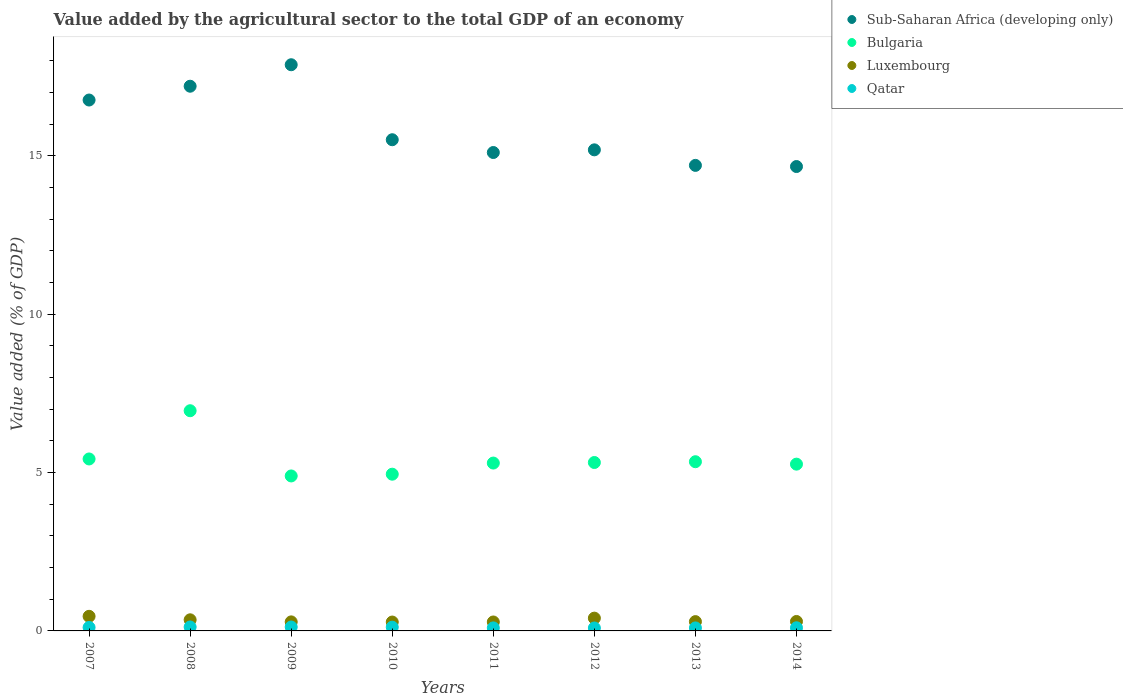How many different coloured dotlines are there?
Ensure brevity in your answer.  4. What is the value added by the agricultural sector to the total GDP in Bulgaria in 2014?
Your response must be concise. 5.27. Across all years, what is the maximum value added by the agricultural sector to the total GDP in Bulgaria?
Provide a succinct answer. 6.95. Across all years, what is the minimum value added by the agricultural sector to the total GDP in Sub-Saharan Africa (developing only)?
Provide a short and direct response. 14.66. What is the total value added by the agricultural sector to the total GDP in Bulgaria in the graph?
Provide a short and direct response. 43.44. What is the difference between the value added by the agricultural sector to the total GDP in Bulgaria in 2007 and that in 2013?
Keep it short and to the point. 0.09. What is the difference between the value added by the agricultural sector to the total GDP in Bulgaria in 2014 and the value added by the agricultural sector to the total GDP in Luxembourg in 2012?
Give a very brief answer. 4.86. What is the average value added by the agricultural sector to the total GDP in Luxembourg per year?
Offer a terse response. 0.33. In the year 2008, what is the difference between the value added by the agricultural sector to the total GDP in Qatar and value added by the agricultural sector to the total GDP in Sub-Saharan Africa (developing only)?
Offer a very short reply. -17.07. What is the ratio of the value added by the agricultural sector to the total GDP in Luxembourg in 2010 to that in 2011?
Offer a terse response. 0.99. Is the value added by the agricultural sector to the total GDP in Luxembourg in 2007 less than that in 2011?
Provide a short and direct response. No. Is the difference between the value added by the agricultural sector to the total GDP in Qatar in 2007 and 2009 greater than the difference between the value added by the agricultural sector to the total GDP in Sub-Saharan Africa (developing only) in 2007 and 2009?
Your answer should be very brief. Yes. What is the difference between the highest and the second highest value added by the agricultural sector to the total GDP in Luxembourg?
Your answer should be very brief. 0.06. What is the difference between the highest and the lowest value added by the agricultural sector to the total GDP in Sub-Saharan Africa (developing only)?
Give a very brief answer. 3.21. In how many years, is the value added by the agricultural sector to the total GDP in Qatar greater than the average value added by the agricultural sector to the total GDP in Qatar taken over all years?
Your response must be concise. 4. How many years are there in the graph?
Your answer should be very brief. 8. What is the difference between two consecutive major ticks on the Y-axis?
Ensure brevity in your answer.  5. Does the graph contain grids?
Give a very brief answer. No. How many legend labels are there?
Provide a succinct answer. 4. How are the legend labels stacked?
Your answer should be compact. Vertical. What is the title of the graph?
Your answer should be compact. Value added by the agricultural sector to the total GDP of an economy. Does "Saudi Arabia" appear as one of the legend labels in the graph?
Your response must be concise. No. What is the label or title of the X-axis?
Offer a terse response. Years. What is the label or title of the Y-axis?
Provide a succinct answer. Value added (% of GDP). What is the Value added (% of GDP) in Sub-Saharan Africa (developing only) in 2007?
Your response must be concise. 16.76. What is the Value added (% of GDP) in Bulgaria in 2007?
Provide a succinct answer. 5.43. What is the Value added (% of GDP) in Luxembourg in 2007?
Provide a short and direct response. 0.46. What is the Value added (% of GDP) in Qatar in 2007?
Your response must be concise. 0.11. What is the Value added (% of GDP) of Sub-Saharan Africa (developing only) in 2008?
Your answer should be very brief. 17.2. What is the Value added (% of GDP) of Bulgaria in 2008?
Offer a very short reply. 6.95. What is the Value added (% of GDP) in Luxembourg in 2008?
Your response must be concise. 0.35. What is the Value added (% of GDP) of Qatar in 2008?
Make the answer very short. 0.12. What is the Value added (% of GDP) in Sub-Saharan Africa (developing only) in 2009?
Provide a succinct answer. 17.87. What is the Value added (% of GDP) of Bulgaria in 2009?
Offer a terse response. 4.89. What is the Value added (% of GDP) in Luxembourg in 2009?
Your answer should be compact. 0.29. What is the Value added (% of GDP) in Qatar in 2009?
Make the answer very short. 0.12. What is the Value added (% of GDP) of Sub-Saharan Africa (developing only) in 2010?
Make the answer very short. 15.51. What is the Value added (% of GDP) of Bulgaria in 2010?
Make the answer very short. 4.95. What is the Value added (% of GDP) of Luxembourg in 2010?
Provide a succinct answer. 0.28. What is the Value added (% of GDP) of Qatar in 2010?
Provide a succinct answer. 0.12. What is the Value added (% of GDP) of Sub-Saharan Africa (developing only) in 2011?
Your answer should be compact. 15.1. What is the Value added (% of GDP) of Bulgaria in 2011?
Your answer should be very brief. 5.3. What is the Value added (% of GDP) of Luxembourg in 2011?
Make the answer very short. 0.28. What is the Value added (% of GDP) in Qatar in 2011?
Keep it short and to the point. 0.1. What is the Value added (% of GDP) in Sub-Saharan Africa (developing only) in 2012?
Provide a succinct answer. 15.19. What is the Value added (% of GDP) of Bulgaria in 2012?
Offer a terse response. 5.32. What is the Value added (% of GDP) in Luxembourg in 2012?
Offer a terse response. 0.4. What is the Value added (% of GDP) of Qatar in 2012?
Provide a short and direct response. 0.09. What is the Value added (% of GDP) of Sub-Saharan Africa (developing only) in 2013?
Offer a very short reply. 14.7. What is the Value added (% of GDP) of Bulgaria in 2013?
Provide a short and direct response. 5.34. What is the Value added (% of GDP) in Luxembourg in 2013?
Provide a short and direct response. 0.29. What is the Value added (% of GDP) of Qatar in 2013?
Provide a succinct answer. 0.09. What is the Value added (% of GDP) in Sub-Saharan Africa (developing only) in 2014?
Offer a very short reply. 14.66. What is the Value added (% of GDP) in Bulgaria in 2014?
Make the answer very short. 5.27. What is the Value added (% of GDP) of Luxembourg in 2014?
Ensure brevity in your answer.  0.3. What is the Value added (% of GDP) in Qatar in 2014?
Your response must be concise. 0.1. Across all years, what is the maximum Value added (% of GDP) in Sub-Saharan Africa (developing only)?
Offer a terse response. 17.87. Across all years, what is the maximum Value added (% of GDP) in Bulgaria?
Offer a terse response. 6.95. Across all years, what is the maximum Value added (% of GDP) of Luxembourg?
Ensure brevity in your answer.  0.46. Across all years, what is the maximum Value added (% of GDP) in Qatar?
Offer a very short reply. 0.12. Across all years, what is the minimum Value added (% of GDP) in Sub-Saharan Africa (developing only)?
Your response must be concise. 14.66. Across all years, what is the minimum Value added (% of GDP) of Bulgaria?
Offer a terse response. 4.89. Across all years, what is the minimum Value added (% of GDP) of Luxembourg?
Provide a short and direct response. 0.28. Across all years, what is the minimum Value added (% of GDP) in Qatar?
Give a very brief answer. 0.09. What is the total Value added (% of GDP) in Sub-Saharan Africa (developing only) in the graph?
Ensure brevity in your answer.  126.98. What is the total Value added (% of GDP) in Bulgaria in the graph?
Offer a terse response. 43.44. What is the total Value added (% of GDP) in Luxembourg in the graph?
Keep it short and to the point. 2.65. What is the total Value added (% of GDP) of Qatar in the graph?
Provide a succinct answer. 0.86. What is the difference between the Value added (% of GDP) of Sub-Saharan Africa (developing only) in 2007 and that in 2008?
Offer a terse response. -0.44. What is the difference between the Value added (% of GDP) of Bulgaria in 2007 and that in 2008?
Your answer should be compact. -1.52. What is the difference between the Value added (% of GDP) of Luxembourg in 2007 and that in 2008?
Your answer should be very brief. 0.11. What is the difference between the Value added (% of GDP) in Qatar in 2007 and that in 2008?
Keep it short and to the point. -0.01. What is the difference between the Value added (% of GDP) of Sub-Saharan Africa (developing only) in 2007 and that in 2009?
Provide a short and direct response. -1.11. What is the difference between the Value added (% of GDP) of Bulgaria in 2007 and that in 2009?
Your answer should be compact. 0.54. What is the difference between the Value added (% of GDP) of Luxembourg in 2007 and that in 2009?
Give a very brief answer. 0.18. What is the difference between the Value added (% of GDP) of Qatar in 2007 and that in 2009?
Offer a terse response. -0.01. What is the difference between the Value added (% of GDP) in Sub-Saharan Africa (developing only) in 2007 and that in 2010?
Provide a short and direct response. 1.25. What is the difference between the Value added (% of GDP) of Bulgaria in 2007 and that in 2010?
Your answer should be very brief. 0.48. What is the difference between the Value added (% of GDP) in Luxembourg in 2007 and that in 2010?
Keep it short and to the point. 0.18. What is the difference between the Value added (% of GDP) in Qatar in 2007 and that in 2010?
Keep it short and to the point. -0.01. What is the difference between the Value added (% of GDP) of Sub-Saharan Africa (developing only) in 2007 and that in 2011?
Provide a short and direct response. 1.66. What is the difference between the Value added (% of GDP) of Bulgaria in 2007 and that in 2011?
Provide a short and direct response. 0.13. What is the difference between the Value added (% of GDP) of Luxembourg in 2007 and that in 2011?
Keep it short and to the point. 0.18. What is the difference between the Value added (% of GDP) in Qatar in 2007 and that in 2011?
Your answer should be compact. 0.01. What is the difference between the Value added (% of GDP) of Sub-Saharan Africa (developing only) in 2007 and that in 2012?
Offer a terse response. 1.57. What is the difference between the Value added (% of GDP) in Bulgaria in 2007 and that in 2012?
Your answer should be compact. 0.11. What is the difference between the Value added (% of GDP) of Luxembourg in 2007 and that in 2012?
Keep it short and to the point. 0.06. What is the difference between the Value added (% of GDP) of Qatar in 2007 and that in 2012?
Provide a succinct answer. 0.02. What is the difference between the Value added (% of GDP) of Sub-Saharan Africa (developing only) in 2007 and that in 2013?
Make the answer very short. 2.06. What is the difference between the Value added (% of GDP) in Bulgaria in 2007 and that in 2013?
Ensure brevity in your answer.  0.09. What is the difference between the Value added (% of GDP) in Luxembourg in 2007 and that in 2013?
Your answer should be compact. 0.17. What is the difference between the Value added (% of GDP) of Qatar in 2007 and that in 2013?
Ensure brevity in your answer.  0.02. What is the difference between the Value added (% of GDP) in Sub-Saharan Africa (developing only) in 2007 and that in 2014?
Your answer should be very brief. 2.1. What is the difference between the Value added (% of GDP) in Bulgaria in 2007 and that in 2014?
Provide a short and direct response. 0.16. What is the difference between the Value added (% of GDP) in Luxembourg in 2007 and that in 2014?
Offer a terse response. 0.16. What is the difference between the Value added (% of GDP) of Qatar in 2007 and that in 2014?
Ensure brevity in your answer.  0.01. What is the difference between the Value added (% of GDP) of Sub-Saharan Africa (developing only) in 2008 and that in 2009?
Ensure brevity in your answer.  -0.68. What is the difference between the Value added (% of GDP) of Bulgaria in 2008 and that in 2009?
Offer a very short reply. 2.06. What is the difference between the Value added (% of GDP) in Luxembourg in 2008 and that in 2009?
Your answer should be compact. 0.07. What is the difference between the Value added (% of GDP) of Qatar in 2008 and that in 2009?
Give a very brief answer. 0. What is the difference between the Value added (% of GDP) of Sub-Saharan Africa (developing only) in 2008 and that in 2010?
Give a very brief answer. 1.69. What is the difference between the Value added (% of GDP) of Bulgaria in 2008 and that in 2010?
Provide a short and direct response. 2. What is the difference between the Value added (% of GDP) of Luxembourg in 2008 and that in 2010?
Your answer should be very brief. 0.07. What is the difference between the Value added (% of GDP) of Qatar in 2008 and that in 2010?
Offer a very short reply. 0.01. What is the difference between the Value added (% of GDP) in Sub-Saharan Africa (developing only) in 2008 and that in 2011?
Your answer should be very brief. 2.09. What is the difference between the Value added (% of GDP) of Bulgaria in 2008 and that in 2011?
Your answer should be very brief. 1.65. What is the difference between the Value added (% of GDP) in Luxembourg in 2008 and that in 2011?
Make the answer very short. 0.07. What is the difference between the Value added (% of GDP) of Qatar in 2008 and that in 2011?
Your answer should be compact. 0.03. What is the difference between the Value added (% of GDP) in Sub-Saharan Africa (developing only) in 2008 and that in 2012?
Your response must be concise. 2.01. What is the difference between the Value added (% of GDP) of Bulgaria in 2008 and that in 2012?
Provide a short and direct response. 1.63. What is the difference between the Value added (% of GDP) of Luxembourg in 2008 and that in 2012?
Offer a very short reply. -0.05. What is the difference between the Value added (% of GDP) in Qatar in 2008 and that in 2012?
Make the answer very short. 0.03. What is the difference between the Value added (% of GDP) of Sub-Saharan Africa (developing only) in 2008 and that in 2013?
Keep it short and to the point. 2.5. What is the difference between the Value added (% of GDP) in Bulgaria in 2008 and that in 2013?
Offer a very short reply. 1.61. What is the difference between the Value added (% of GDP) in Luxembourg in 2008 and that in 2013?
Offer a terse response. 0.06. What is the difference between the Value added (% of GDP) of Qatar in 2008 and that in 2013?
Give a very brief answer. 0.03. What is the difference between the Value added (% of GDP) in Sub-Saharan Africa (developing only) in 2008 and that in 2014?
Give a very brief answer. 2.54. What is the difference between the Value added (% of GDP) of Bulgaria in 2008 and that in 2014?
Your answer should be compact. 1.69. What is the difference between the Value added (% of GDP) of Luxembourg in 2008 and that in 2014?
Your answer should be very brief. 0.05. What is the difference between the Value added (% of GDP) of Qatar in 2008 and that in 2014?
Offer a terse response. 0.03. What is the difference between the Value added (% of GDP) of Sub-Saharan Africa (developing only) in 2009 and that in 2010?
Offer a terse response. 2.37. What is the difference between the Value added (% of GDP) in Bulgaria in 2009 and that in 2010?
Offer a very short reply. -0.06. What is the difference between the Value added (% of GDP) in Luxembourg in 2009 and that in 2010?
Provide a succinct answer. 0.01. What is the difference between the Value added (% of GDP) of Qatar in 2009 and that in 2010?
Provide a short and direct response. 0.01. What is the difference between the Value added (% of GDP) in Sub-Saharan Africa (developing only) in 2009 and that in 2011?
Keep it short and to the point. 2.77. What is the difference between the Value added (% of GDP) in Bulgaria in 2009 and that in 2011?
Your response must be concise. -0.41. What is the difference between the Value added (% of GDP) in Luxembourg in 2009 and that in 2011?
Provide a succinct answer. 0. What is the difference between the Value added (% of GDP) in Qatar in 2009 and that in 2011?
Offer a very short reply. 0.03. What is the difference between the Value added (% of GDP) in Sub-Saharan Africa (developing only) in 2009 and that in 2012?
Offer a terse response. 2.69. What is the difference between the Value added (% of GDP) in Bulgaria in 2009 and that in 2012?
Offer a terse response. -0.42. What is the difference between the Value added (% of GDP) of Luxembourg in 2009 and that in 2012?
Offer a terse response. -0.12. What is the difference between the Value added (% of GDP) in Qatar in 2009 and that in 2012?
Your response must be concise. 0.03. What is the difference between the Value added (% of GDP) in Sub-Saharan Africa (developing only) in 2009 and that in 2013?
Offer a very short reply. 3.18. What is the difference between the Value added (% of GDP) in Bulgaria in 2009 and that in 2013?
Offer a very short reply. -0.45. What is the difference between the Value added (% of GDP) of Luxembourg in 2009 and that in 2013?
Your response must be concise. -0.01. What is the difference between the Value added (% of GDP) in Qatar in 2009 and that in 2013?
Your response must be concise. 0.03. What is the difference between the Value added (% of GDP) of Sub-Saharan Africa (developing only) in 2009 and that in 2014?
Offer a very short reply. 3.21. What is the difference between the Value added (% of GDP) of Bulgaria in 2009 and that in 2014?
Your answer should be compact. -0.37. What is the difference between the Value added (% of GDP) of Luxembourg in 2009 and that in 2014?
Keep it short and to the point. -0.01. What is the difference between the Value added (% of GDP) of Qatar in 2009 and that in 2014?
Your answer should be very brief. 0.02. What is the difference between the Value added (% of GDP) in Sub-Saharan Africa (developing only) in 2010 and that in 2011?
Offer a terse response. 0.4. What is the difference between the Value added (% of GDP) of Bulgaria in 2010 and that in 2011?
Your answer should be compact. -0.35. What is the difference between the Value added (% of GDP) in Luxembourg in 2010 and that in 2011?
Provide a succinct answer. -0. What is the difference between the Value added (% of GDP) in Qatar in 2010 and that in 2011?
Your answer should be compact. 0.02. What is the difference between the Value added (% of GDP) in Sub-Saharan Africa (developing only) in 2010 and that in 2012?
Give a very brief answer. 0.32. What is the difference between the Value added (% of GDP) in Bulgaria in 2010 and that in 2012?
Provide a short and direct response. -0.37. What is the difference between the Value added (% of GDP) of Luxembourg in 2010 and that in 2012?
Provide a succinct answer. -0.12. What is the difference between the Value added (% of GDP) of Qatar in 2010 and that in 2012?
Offer a terse response. 0.03. What is the difference between the Value added (% of GDP) of Sub-Saharan Africa (developing only) in 2010 and that in 2013?
Keep it short and to the point. 0.81. What is the difference between the Value added (% of GDP) of Bulgaria in 2010 and that in 2013?
Make the answer very short. -0.39. What is the difference between the Value added (% of GDP) of Luxembourg in 2010 and that in 2013?
Offer a very short reply. -0.01. What is the difference between the Value added (% of GDP) of Qatar in 2010 and that in 2013?
Keep it short and to the point. 0.02. What is the difference between the Value added (% of GDP) in Sub-Saharan Africa (developing only) in 2010 and that in 2014?
Your answer should be very brief. 0.85. What is the difference between the Value added (% of GDP) in Bulgaria in 2010 and that in 2014?
Provide a short and direct response. -0.32. What is the difference between the Value added (% of GDP) of Luxembourg in 2010 and that in 2014?
Provide a succinct answer. -0.02. What is the difference between the Value added (% of GDP) in Qatar in 2010 and that in 2014?
Offer a very short reply. 0.02. What is the difference between the Value added (% of GDP) in Sub-Saharan Africa (developing only) in 2011 and that in 2012?
Offer a very short reply. -0.08. What is the difference between the Value added (% of GDP) of Bulgaria in 2011 and that in 2012?
Provide a succinct answer. -0.02. What is the difference between the Value added (% of GDP) of Luxembourg in 2011 and that in 2012?
Offer a very short reply. -0.12. What is the difference between the Value added (% of GDP) of Qatar in 2011 and that in 2012?
Make the answer very short. 0. What is the difference between the Value added (% of GDP) in Sub-Saharan Africa (developing only) in 2011 and that in 2013?
Make the answer very short. 0.41. What is the difference between the Value added (% of GDP) of Bulgaria in 2011 and that in 2013?
Ensure brevity in your answer.  -0.04. What is the difference between the Value added (% of GDP) of Luxembourg in 2011 and that in 2013?
Offer a very short reply. -0.01. What is the difference between the Value added (% of GDP) in Qatar in 2011 and that in 2013?
Make the answer very short. 0. What is the difference between the Value added (% of GDP) of Sub-Saharan Africa (developing only) in 2011 and that in 2014?
Make the answer very short. 0.44. What is the difference between the Value added (% of GDP) in Bulgaria in 2011 and that in 2014?
Provide a succinct answer. 0.03. What is the difference between the Value added (% of GDP) of Luxembourg in 2011 and that in 2014?
Make the answer very short. -0.02. What is the difference between the Value added (% of GDP) of Qatar in 2011 and that in 2014?
Provide a short and direct response. -0. What is the difference between the Value added (% of GDP) in Sub-Saharan Africa (developing only) in 2012 and that in 2013?
Give a very brief answer. 0.49. What is the difference between the Value added (% of GDP) of Bulgaria in 2012 and that in 2013?
Your response must be concise. -0.02. What is the difference between the Value added (% of GDP) in Luxembourg in 2012 and that in 2013?
Ensure brevity in your answer.  0.11. What is the difference between the Value added (% of GDP) of Qatar in 2012 and that in 2013?
Make the answer very short. -0. What is the difference between the Value added (% of GDP) of Sub-Saharan Africa (developing only) in 2012 and that in 2014?
Your response must be concise. 0.53. What is the difference between the Value added (% of GDP) of Bulgaria in 2012 and that in 2014?
Provide a succinct answer. 0.05. What is the difference between the Value added (% of GDP) in Luxembourg in 2012 and that in 2014?
Your answer should be very brief. 0.11. What is the difference between the Value added (% of GDP) in Qatar in 2012 and that in 2014?
Your response must be concise. -0.01. What is the difference between the Value added (% of GDP) of Sub-Saharan Africa (developing only) in 2013 and that in 2014?
Ensure brevity in your answer.  0.04. What is the difference between the Value added (% of GDP) in Bulgaria in 2013 and that in 2014?
Offer a very short reply. 0.08. What is the difference between the Value added (% of GDP) in Luxembourg in 2013 and that in 2014?
Make the answer very short. -0. What is the difference between the Value added (% of GDP) of Qatar in 2013 and that in 2014?
Offer a terse response. -0. What is the difference between the Value added (% of GDP) in Sub-Saharan Africa (developing only) in 2007 and the Value added (% of GDP) in Bulgaria in 2008?
Your answer should be compact. 9.81. What is the difference between the Value added (% of GDP) of Sub-Saharan Africa (developing only) in 2007 and the Value added (% of GDP) of Luxembourg in 2008?
Provide a succinct answer. 16.41. What is the difference between the Value added (% of GDP) of Sub-Saharan Africa (developing only) in 2007 and the Value added (% of GDP) of Qatar in 2008?
Provide a short and direct response. 16.64. What is the difference between the Value added (% of GDP) in Bulgaria in 2007 and the Value added (% of GDP) in Luxembourg in 2008?
Offer a terse response. 5.08. What is the difference between the Value added (% of GDP) in Bulgaria in 2007 and the Value added (% of GDP) in Qatar in 2008?
Offer a very short reply. 5.3. What is the difference between the Value added (% of GDP) in Luxembourg in 2007 and the Value added (% of GDP) in Qatar in 2008?
Your answer should be compact. 0.34. What is the difference between the Value added (% of GDP) of Sub-Saharan Africa (developing only) in 2007 and the Value added (% of GDP) of Bulgaria in 2009?
Your response must be concise. 11.87. What is the difference between the Value added (% of GDP) of Sub-Saharan Africa (developing only) in 2007 and the Value added (% of GDP) of Luxembourg in 2009?
Provide a short and direct response. 16.47. What is the difference between the Value added (% of GDP) in Sub-Saharan Africa (developing only) in 2007 and the Value added (% of GDP) in Qatar in 2009?
Offer a terse response. 16.64. What is the difference between the Value added (% of GDP) in Bulgaria in 2007 and the Value added (% of GDP) in Luxembourg in 2009?
Your answer should be compact. 5.14. What is the difference between the Value added (% of GDP) of Bulgaria in 2007 and the Value added (% of GDP) of Qatar in 2009?
Your response must be concise. 5.31. What is the difference between the Value added (% of GDP) in Luxembourg in 2007 and the Value added (% of GDP) in Qatar in 2009?
Provide a short and direct response. 0.34. What is the difference between the Value added (% of GDP) in Sub-Saharan Africa (developing only) in 2007 and the Value added (% of GDP) in Bulgaria in 2010?
Your response must be concise. 11.81. What is the difference between the Value added (% of GDP) in Sub-Saharan Africa (developing only) in 2007 and the Value added (% of GDP) in Luxembourg in 2010?
Keep it short and to the point. 16.48. What is the difference between the Value added (% of GDP) of Sub-Saharan Africa (developing only) in 2007 and the Value added (% of GDP) of Qatar in 2010?
Keep it short and to the point. 16.64. What is the difference between the Value added (% of GDP) of Bulgaria in 2007 and the Value added (% of GDP) of Luxembourg in 2010?
Ensure brevity in your answer.  5.15. What is the difference between the Value added (% of GDP) in Bulgaria in 2007 and the Value added (% of GDP) in Qatar in 2010?
Your answer should be very brief. 5.31. What is the difference between the Value added (% of GDP) of Luxembourg in 2007 and the Value added (% of GDP) of Qatar in 2010?
Provide a succinct answer. 0.34. What is the difference between the Value added (% of GDP) in Sub-Saharan Africa (developing only) in 2007 and the Value added (% of GDP) in Bulgaria in 2011?
Your answer should be very brief. 11.46. What is the difference between the Value added (% of GDP) of Sub-Saharan Africa (developing only) in 2007 and the Value added (% of GDP) of Luxembourg in 2011?
Give a very brief answer. 16.48. What is the difference between the Value added (% of GDP) in Sub-Saharan Africa (developing only) in 2007 and the Value added (% of GDP) in Qatar in 2011?
Give a very brief answer. 16.66. What is the difference between the Value added (% of GDP) in Bulgaria in 2007 and the Value added (% of GDP) in Luxembourg in 2011?
Provide a short and direct response. 5.15. What is the difference between the Value added (% of GDP) in Bulgaria in 2007 and the Value added (% of GDP) in Qatar in 2011?
Give a very brief answer. 5.33. What is the difference between the Value added (% of GDP) of Luxembourg in 2007 and the Value added (% of GDP) of Qatar in 2011?
Offer a terse response. 0.37. What is the difference between the Value added (% of GDP) in Sub-Saharan Africa (developing only) in 2007 and the Value added (% of GDP) in Bulgaria in 2012?
Provide a short and direct response. 11.44. What is the difference between the Value added (% of GDP) of Sub-Saharan Africa (developing only) in 2007 and the Value added (% of GDP) of Luxembourg in 2012?
Ensure brevity in your answer.  16.36. What is the difference between the Value added (% of GDP) of Sub-Saharan Africa (developing only) in 2007 and the Value added (% of GDP) of Qatar in 2012?
Your answer should be very brief. 16.67. What is the difference between the Value added (% of GDP) of Bulgaria in 2007 and the Value added (% of GDP) of Luxembourg in 2012?
Offer a very short reply. 5.03. What is the difference between the Value added (% of GDP) of Bulgaria in 2007 and the Value added (% of GDP) of Qatar in 2012?
Provide a short and direct response. 5.34. What is the difference between the Value added (% of GDP) in Luxembourg in 2007 and the Value added (% of GDP) in Qatar in 2012?
Give a very brief answer. 0.37. What is the difference between the Value added (% of GDP) in Sub-Saharan Africa (developing only) in 2007 and the Value added (% of GDP) in Bulgaria in 2013?
Your answer should be compact. 11.42. What is the difference between the Value added (% of GDP) in Sub-Saharan Africa (developing only) in 2007 and the Value added (% of GDP) in Luxembourg in 2013?
Provide a succinct answer. 16.47. What is the difference between the Value added (% of GDP) in Sub-Saharan Africa (developing only) in 2007 and the Value added (% of GDP) in Qatar in 2013?
Ensure brevity in your answer.  16.67. What is the difference between the Value added (% of GDP) in Bulgaria in 2007 and the Value added (% of GDP) in Luxembourg in 2013?
Provide a succinct answer. 5.14. What is the difference between the Value added (% of GDP) in Bulgaria in 2007 and the Value added (% of GDP) in Qatar in 2013?
Keep it short and to the point. 5.33. What is the difference between the Value added (% of GDP) of Luxembourg in 2007 and the Value added (% of GDP) of Qatar in 2013?
Your answer should be very brief. 0.37. What is the difference between the Value added (% of GDP) in Sub-Saharan Africa (developing only) in 2007 and the Value added (% of GDP) in Bulgaria in 2014?
Make the answer very short. 11.49. What is the difference between the Value added (% of GDP) in Sub-Saharan Africa (developing only) in 2007 and the Value added (% of GDP) in Luxembourg in 2014?
Provide a succinct answer. 16.46. What is the difference between the Value added (% of GDP) of Sub-Saharan Africa (developing only) in 2007 and the Value added (% of GDP) of Qatar in 2014?
Your answer should be compact. 16.66. What is the difference between the Value added (% of GDP) in Bulgaria in 2007 and the Value added (% of GDP) in Luxembourg in 2014?
Offer a terse response. 5.13. What is the difference between the Value added (% of GDP) in Bulgaria in 2007 and the Value added (% of GDP) in Qatar in 2014?
Keep it short and to the point. 5.33. What is the difference between the Value added (% of GDP) in Luxembourg in 2007 and the Value added (% of GDP) in Qatar in 2014?
Your answer should be very brief. 0.36. What is the difference between the Value added (% of GDP) of Sub-Saharan Africa (developing only) in 2008 and the Value added (% of GDP) of Bulgaria in 2009?
Ensure brevity in your answer.  12.3. What is the difference between the Value added (% of GDP) of Sub-Saharan Africa (developing only) in 2008 and the Value added (% of GDP) of Luxembourg in 2009?
Your response must be concise. 16.91. What is the difference between the Value added (% of GDP) in Sub-Saharan Africa (developing only) in 2008 and the Value added (% of GDP) in Qatar in 2009?
Your answer should be compact. 17.07. What is the difference between the Value added (% of GDP) in Bulgaria in 2008 and the Value added (% of GDP) in Luxembourg in 2009?
Keep it short and to the point. 6.67. What is the difference between the Value added (% of GDP) in Bulgaria in 2008 and the Value added (% of GDP) in Qatar in 2009?
Provide a succinct answer. 6.83. What is the difference between the Value added (% of GDP) of Luxembourg in 2008 and the Value added (% of GDP) of Qatar in 2009?
Make the answer very short. 0.23. What is the difference between the Value added (% of GDP) in Sub-Saharan Africa (developing only) in 2008 and the Value added (% of GDP) in Bulgaria in 2010?
Ensure brevity in your answer.  12.25. What is the difference between the Value added (% of GDP) of Sub-Saharan Africa (developing only) in 2008 and the Value added (% of GDP) of Luxembourg in 2010?
Keep it short and to the point. 16.92. What is the difference between the Value added (% of GDP) of Sub-Saharan Africa (developing only) in 2008 and the Value added (% of GDP) of Qatar in 2010?
Provide a succinct answer. 17.08. What is the difference between the Value added (% of GDP) in Bulgaria in 2008 and the Value added (% of GDP) in Luxembourg in 2010?
Make the answer very short. 6.67. What is the difference between the Value added (% of GDP) in Bulgaria in 2008 and the Value added (% of GDP) in Qatar in 2010?
Your response must be concise. 6.83. What is the difference between the Value added (% of GDP) in Luxembourg in 2008 and the Value added (% of GDP) in Qatar in 2010?
Offer a terse response. 0.23. What is the difference between the Value added (% of GDP) in Sub-Saharan Africa (developing only) in 2008 and the Value added (% of GDP) in Bulgaria in 2011?
Your answer should be very brief. 11.9. What is the difference between the Value added (% of GDP) of Sub-Saharan Africa (developing only) in 2008 and the Value added (% of GDP) of Luxembourg in 2011?
Your answer should be compact. 16.91. What is the difference between the Value added (% of GDP) in Sub-Saharan Africa (developing only) in 2008 and the Value added (% of GDP) in Qatar in 2011?
Provide a succinct answer. 17.1. What is the difference between the Value added (% of GDP) of Bulgaria in 2008 and the Value added (% of GDP) of Luxembourg in 2011?
Provide a short and direct response. 6.67. What is the difference between the Value added (% of GDP) of Bulgaria in 2008 and the Value added (% of GDP) of Qatar in 2011?
Your response must be concise. 6.86. What is the difference between the Value added (% of GDP) of Luxembourg in 2008 and the Value added (% of GDP) of Qatar in 2011?
Give a very brief answer. 0.26. What is the difference between the Value added (% of GDP) of Sub-Saharan Africa (developing only) in 2008 and the Value added (% of GDP) of Bulgaria in 2012?
Your response must be concise. 11.88. What is the difference between the Value added (% of GDP) in Sub-Saharan Africa (developing only) in 2008 and the Value added (% of GDP) in Luxembourg in 2012?
Ensure brevity in your answer.  16.79. What is the difference between the Value added (% of GDP) of Sub-Saharan Africa (developing only) in 2008 and the Value added (% of GDP) of Qatar in 2012?
Provide a succinct answer. 17.1. What is the difference between the Value added (% of GDP) in Bulgaria in 2008 and the Value added (% of GDP) in Luxembourg in 2012?
Your response must be concise. 6.55. What is the difference between the Value added (% of GDP) in Bulgaria in 2008 and the Value added (% of GDP) in Qatar in 2012?
Ensure brevity in your answer.  6.86. What is the difference between the Value added (% of GDP) in Luxembourg in 2008 and the Value added (% of GDP) in Qatar in 2012?
Keep it short and to the point. 0.26. What is the difference between the Value added (% of GDP) of Sub-Saharan Africa (developing only) in 2008 and the Value added (% of GDP) of Bulgaria in 2013?
Make the answer very short. 11.85. What is the difference between the Value added (% of GDP) of Sub-Saharan Africa (developing only) in 2008 and the Value added (% of GDP) of Luxembourg in 2013?
Provide a succinct answer. 16.9. What is the difference between the Value added (% of GDP) of Sub-Saharan Africa (developing only) in 2008 and the Value added (% of GDP) of Qatar in 2013?
Your response must be concise. 17.1. What is the difference between the Value added (% of GDP) of Bulgaria in 2008 and the Value added (% of GDP) of Luxembourg in 2013?
Your answer should be very brief. 6.66. What is the difference between the Value added (% of GDP) in Bulgaria in 2008 and the Value added (% of GDP) in Qatar in 2013?
Your response must be concise. 6.86. What is the difference between the Value added (% of GDP) in Luxembourg in 2008 and the Value added (% of GDP) in Qatar in 2013?
Ensure brevity in your answer.  0.26. What is the difference between the Value added (% of GDP) in Sub-Saharan Africa (developing only) in 2008 and the Value added (% of GDP) in Bulgaria in 2014?
Offer a terse response. 11.93. What is the difference between the Value added (% of GDP) of Sub-Saharan Africa (developing only) in 2008 and the Value added (% of GDP) of Luxembourg in 2014?
Your answer should be very brief. 16.9. What is the difference between the Value added (% of GDP) of Sub-Saharan Africa (developing only) in 2008 and the Value added (% of GDP) of Qatar in 2014?
Give a very brief answer. 17.1. What is the difference between the Value added (% of GDP) of Bulgaria in 2008 and the Value added (% of GDP) of Luxembourg in 2014?
Your response must be concise. 6.65. What is the difference between the Value added (% of GDP) in Bulgaria in 2008 and the Value added (% of GDP) in Qatar in 2014?
Provide a succinct answer. 6.85. What is the difference between the Value added (% of GDP) in Luxembourg in 2008 and the Value added (% of GDP) in Qatar in 2014?
Give a very brief answer. 0.25. What is the difference between the Value added (% of GDP) in Sub-Saharan Africa (developing only) in 2009 and the Value added (% of GDP) in Bulgaria in 2010?
Keep it short and to the point. 12.93. What is the difference between the Value added (% of GDP) in Sub-Saharan Africa (developing only) in 2009 and the Value added (% of GDP) in Luxembourg in 2010?
Provide a succinct answer. 17.59. What is the difference between the Value added (% of GDP) of Sub-Saharan Africa (developing only) in 2009 and the Value added (% of GDP) of Qatar in 2010?
Your answer should be very brief. 17.76. What is the difference between the Value added (% of GDP) in Bulgaria in 2009 and the Value added (% of GDP) in Luxembourg in 2010?
Make the answer very short. 4.61. What is the difference between the Value added (% of GDP) of Bulgaria in 2009 and the Value added (% of GDP) of Qatar in 2010?
Your response must be concise. 4.77. What is the difference between the Value added (% of GDP) of Luxembourg in 2009 and the Value added (% of GDP) of Qatar in 2010?
Your response must be concise. 0.17. What is the difference between the Value added (% of GDP) in Sub-Saharan Africa (developing only) in 2009 and the Value added (% of GDP) in Bulgaria in 2011?
Offer a terse response. 12.57. What is the difference between the Value added (% of GDP) in Sub-Saharan Africa (developing only) in 2009 and the Value added (% of GDP) in Luxembourg in 2011?
Your answer should be compact. 17.59. What is the difference between the Value added (% of GDP) in Sub-Saharan Africa (developing only) in 2009 and the Value added (% of GDP) in Qatar in 2011?
Offer a terse response. 17.78. What is the difference between the Value added (% of GDP) in Bulgaria in 2009 and the Value added (% of GDP) in Luxembourg in 2011?
Your answer should be very brief. 4.61. What is the difference between the Value added (% of GDP) in Bulgaria in 2009 and the Value added (% of GDP) in Qatar in 2011?
Your response must be concise. 4.8. What is the difference between the Value added (% of GDP) of Luxembourg in 2009 and the Value added (% of GDP) of Qatar in 2011?
Offer a very short reply. 0.19. What is the difference between the Value added (% of GDP) in Sub-Saharan Africa (developing only) in 2009 and the Value added (% of GDP) in Bulgaria in 2012?
Ensure brevity in your answer.  12.56. What is the difference between the Value added (% of GDP) of Sub-Saharan Africa (developing only) in 2009 and the Value added (% of GDP) of Luxembourg in 2012?
Offer a very short reply. 17.47. What is the difference between the Value added (% of GDP) in Sub-Saharan Africa (developing only) in 2009 and the Value added (% of GDP) in Qatar in 2012?
Provide a succinct answer. 17.78. What is the difference between the Value added (% of GDP) in Bulgaria in 2009 and the Value added (% of GDP) in Luxembourg in 2012?
Provide a short and direct response. 4.49. What is the difference between the Value added (% of GDP) in Bulgaria in 2009 and the Value added (% of GDP) in Qatar in 2012?
Provide a short and direct response. 4.8. What is the difference between the Value added (% of GDP) of Luxembourg in 2009 and the Value added (% of GDP) of Qatar in 2012?
Provide a succinct answer. 0.19. What is the difference between the Value added (% of GDP) in Sub-Saharan Africa (developing only) in 2009 and the Value added (% of GDP) in Bulgaria in 2013?
Make the answer very short. 12.53. What is the difference between the Value added (% of GDP) of Sub-Saharan Africa (developing only) in 2009 and the Value added (% of GDP) of Luxembourg in 2013?
Your answer should be compact. 17.58. What is the difference between the Value added (% of GDP) in Sub-Saharan Africa (developing only) in 2009 and the Value added (% of GDP) in Qatar in 2013?
Give a very brief answer. 17.78. What is the difference between the Value added (% of GDP) of Bulgaria in 2009 and the Value added (% of GDP) of Luxembourg in 2013?
Your answer should be compact. 4.6. What is the difference between the Value added (% of GDP) of Bulgaria in 2009 and the Value added (% of GDP) of Qatar in 2013?
Offer a very short reply. 4.8. What is the difference between the Value added (% of GDP) of Luxembourg in 2009 and the Value added (% of GDP) of Qatar in 2013?
Your response must be concise. 0.19. What is the difference between the Value added (% of GDP) in Sub-Saharan Africa (developing only) in 2009 and the Value added (% of GDP) in Bulgaria in 2014?
Ensure brevity in your answer.  12.61. What is the difference between the Value added (% of GDP) in Sub-Saharan Africa (developing only) in 2009 and the Value added (% of GDP) in Luxembourg in 2014?
Give a very brief answer. 17.58. What is the difference between the Value added (% of GDP) in Sub-Saharan Africa (developing only) in 2009 and the Value added (% of GDP) in Qatar in 2014?
Provide a short and direct response. 17.77. What is the difference between the Value added (% of GDP) in Bulgaria in 2009 and the Value added (% of GDP) in Luxembourg in 2014?
Your answer should be very brief. 4.59. What is the difference between the Value added (% of GDP) in Bulgaria in 2009 and the Value added (% of GDP) in Qatar in 2014?
Give a very brief answer. 4.79. What is the difference between the Value added (% of GDP) of Luxembourg in 2009 and the Value added (% of GDP) of Qatar in 2014?
Your answer should be compact. 0.19. What is the difference between the Value added (% of GDP) in Sub-Saharan Africa (developing only) in 2010 and the Value added (% of GDP) in Bulgaria in 2011?
Provide a succinct answer. 10.21. What is the difference between the Value added (% of GDP) in Sub-Saharan Africa (developing only) in 2010 and the Value added (% of GDP) in Luxembourg in 2011?
Your answer should be compact. 15.22. What is the difference between the Value added (% of GDP) in Sub-Saharan Africa (developing only) in 2010 and the Value added (% of GDP) in Qatar in 2011?
Your answer should be very brief. 15.41. What is the difference between the Value added (% of GDP) of Bulgaria in 2010 and the Value added (% of GDP) of Luxembourg in 2011?
Your answer should be compact. 4.67. What is the difference between the Value added (% of GDP) in Bulgaria in 2010 and the Value added (% of GDP) in Qatar in 2011?
Your answer should be compact. 4.85. What is the difference between the Value added (% of GDP) in Luxembourg in 2010 and the Value added (% of GDP) in Qatar in 2011?
Offer a terse response. 0.18. What is the difference between the Value added (% of GDP) of Sub-Saharan Africa (developing only) in 2010 and the Value added (% of GDP) of Bulgaria in 2012?
Your response must be concise. 10.19. What is the difference between the Value added (% of GDP) in Sub-Saharan Africa (developing only) in 2010 and the Value added (% of GDP) in Luxembourg in 2012?
Offer a terse response. 15.1. What is the difference between the Value added (% of GDP) of Sub-Saharan Africa (developing only) in 2010 and the Value added (% of GDP) of Qatar in 2012?
Your response must be concise. 15.41. What is the difference between the Value added (% of GDP) in Bulgaria in 2010 and the Value added (% of GDP) in Luxembourg in 2012?
Keep it short and to the point. 4.54. What is the difference between the Value added (% of GDP) of Bulgaria in 2010 and the Value added (% of GDP) of Qatar in 2012?
Offer a very short reply. 4.86. What is the difference between the Value added (% of GDP) in Luxembourg in 2010 and the Value added (% of GDP) in Qatar in 2012?
Keep it short and to the point. 0.19. What is the difference between the Value added (% of GDP) of Sub-Saharan Africa (developing only) in 2010 and the Value added (% of GDP) of Bulgaria in 2013?
Keep it short and to the point. 10.16. What is the difference between the Value added (% of GDP) of Sub-Saharan Africa (developing only) in 2010 and the Value added (% of GDP) of Luxembourg in 2013?
Your response must be concise. 15.21. What is the difference between the Value added (% of GDP) of Sub-Saharan Africa (developing only) in 2010 and the Value added (% of GDP) of Qatar in 2013?
Give a very brief answer. 15.41. What is the difference between the Value added (% of GDP) in Bulgaria in 2010 and the Value added (% of GDP) in Luxembourg in 2013?
Your answer should be compact. 4.65. What is the difference between the Value added (% of GDP) of Bulgaria in 2010 and the Value added (% of GDP) of Qatar in 2013?
Provide a short and direct response. 4.85. What is the difference between the Value added (% of GDP) of Luxembourg in 2010 and the Value added (% of GDP) of Qatar in 2013?
Ensure brevity in your answer.  0.19. What is the difference between the Value added (% of GDP) of Sub-Saharan Africa (developing only) in 2010 and the Value added (% of GDP) of Bulgaria in 2014?
Provide a short and direct response. 10.24. What is the difference between the Value added (% of GDP) of Sub-Saharan Africa (developing only) in 2010 and the Value added (% of GDP) of Luxembourg in 2014?
Provide a succinct answer. 15.21. What is the difference between the Value added (% of GDP) in Sub-Saharan Africa (developing only) in 2010 and the Value added (% of GDP) in Qatar in 2014?
Make the answer very short. 15.41. What is the difference between the Value added (% of GDP) in Bulgaria in 2010 and the Value added (% of GDP) in Luxembourg in 2014?
Offer a terse response. 4.65. What is the difference between the Value added (% of GDP) in Bulgaria in 2010 and the Value added (% of GDP) in Qatar in 2014?
Your answer should be compact. 4.85. What is the difference between the Value added (% of GDP) in Luxembourg in 2010 and the Value added (% of GDP) in Qatar in 2014?
Make the answer very short. 0.18. What is the difference between the Value added (% of GDP) of Sub-Saharan Africa (developing only) in 2011 and the Value added (% of GDP) of Bulgaria in 2012?
Provide a short and direct response. 9.79. What is the difference between the Value added (% of GDP) of Sub-Saharan Africa (developing only) in 2011 and the Value added (% of GDP) of Luxembourg in 2012?
Give a very brief answer. 14.7. What is the difference between the Value added (% of GDP) of Sub-Saharan Africa (developing only) in 2011 and the Value added (% of GDP) of Qatar in 2012?
Ensure brevity in your answer.  15.01. What is the difference between the Value added (% of GDP) in Bulgaria in 2011 and the Value added (% of GDP) in Luxembourg in 2012?
Your answer should be compact. 4.9. What is the difference between the Value added (% of GDP) in Bulgaria in 2011 and the Value added (% of GDP) in Qatar in 2012?
Give a very brief answer. 5.21. What is the difference between the Value added (% of GDP) of Luxembourg in 2011 and the Value added (% of GDP) of Qatar in 2012?
Keep it short and to the point. 0.19. What is the difference between the Value added (% of GDP) in Sub-Saharan Africa (developing only) in 2011 and the Value added (% of GDP) in Bulgaria in 2013?
Keep it short and to the point. 9.76. What is the difference between the Value added (% of GDP) of Sub-Saharan Africa (developing only) in 2011 and the Value added (% of GDP) of Luxembourg in 2013?
Offer a terse response. 14.81. What is the difference between the Value added (% of GDP) in Sub-Saharan Africa (developing only) in 2011 and the Value added (% of GDP) in Qatar in 2013?
Give a very brief answer. 15.01. What is the difference between the Value added (% of GDP) in Bulgaria in 2011 and the Value added (% of GDP) in Luxembourg in 2013?
Offer a terse response. 5.01. What is the difference between the Value added (% of GDP) in Bulgaria in 2011 and the Value added (% of GDP) in Qatar in 2013?
Your answer should be very brief. 5.2. What is the difference between the Value added (% of GDP) of Luxembourg in 2011 and the Value added (% of GDP) of Qatar in 2013?
Your answer should be very brief. 0.19. What is the difference between the Value added (% of GDP) in Sub-Saharan Africa (developing only) in 2011 and the Value added (% of GDP) in Bulgaria in 2014?
Your response must be concise. 9.84. What is the difference between the Value added (% of GDP) of Sub-Saharan Africa (developing only) in 2011 and the Value added (% of GDP) of Luxembourg in 2014?
Provide a succinct answer. 14.8. What is the difference between the Value added (% of GDP) in Sub-Saharan Africa (developing only) in 2011 and the Value added (% of GDP) in Qatar in 2014?
Make the answer very short. 15. What is the difference between the Value added (% of GDP) in Bulgaria in 2011 and the Value added (% of GDP) in Luxembourg in 2014?
Ensure brevity in your answer.  5. What is the difference between the Value added (% of GDP) in Bulgaria in 2011 and the Value added (% of GDP) in Qatar in 2014?
Your answer should be compact. 5.2. What is the difference between the Value added (% of GDP) in Luxembourg in 2011 and the Value added (% of GDP) in Qatar in 2014?
Provide a succinct answer. 0.18. What is the difference between the Value added (% of GDP) in Sub-Saharan Africa (developing only) in 2012 and the Value added (% of GDP) in Bulgaria in 2013?
Your answer should be compact. 9.85. What is the difference between the Value added (% of GDP) of Sub-Saharan Africa (developing only) in 2012 and the Value added (% of GDP) of Luxembourg in 2013?
Offer a very short reply. 14.89. What is the difference between the Value added (% of GDP) of Sub-Saharan Africa (developing only) in 2012 and the Value added (% of GDP) of Qatar in 2013?
Your response must be concise. 15.09. What is the difference between the Value added (% of GDP) of Bulgaria in 2012 and the Value added (% of GDP) of Luxembourg in 2013?
Your response must be concise. 5.02. What is the difference between the Value added (% of GDP) of Bulgaria in 2012 and the Value added (% of GDP) of Qatar in 2013?
Provide a succinct answer. 5.22. What is the difference between the Value added (% of GDP) of Luxembourg in 2012 and the Value added (% of GDP) of Qatar in 2013?
Ensure brevity in your answer.  0.31. What is the difference between the Value added (% of GDP) of Sub-Saharan Africa (developing only) in 2012 and the Value added (% of GDP) of Bulgaria in 2014?
Keep it short and to the point. 9.92. What is the difference between the Value added (% of GDP) of Sub-Saharan Africa (developing only) in 2012 and the Value added (% of GDP) of Luxembourg in 2014?
Give a very brief answer. 14.89. What is the difference between the Value added (% of GDP) of Sub-Saharan Africa (developing only) in 2012 and the Value added (% of GDP) of Qatar in 2014?
Offer a very short reply. 15.09. What is the difference between the Value added (% of GDP) of Bulgaria in 2012 and the Value added (% of GDP) of Luxembourg in 2014?
Make the answer very short. 5.02. What is the difference between the Value added (% of GDP) in Bulgaria in 2012 and the Value added (% of GDP) in Qatar in 2014?
Offer a terse response. 5.22. What is the difference between the Value added (% of GDP) of Luxembourg in 2012 and the Value added (% of GDP) of Qatar in 2014?
Your answer should be compact. 0.3. What is the difference between the Value added (% of GDP) of Sub-Saharan Africa (developing only) in 2013 and the Value added (% of GDP) of Bulgaria in 2014?
Ensure brevity in your answer.  9.43. What is the difference between the Value added (% of GDP) in Sub-Saharan Africa (developing only) in 2013 and the Value added (% of GDP) in Luxembourg in 2014?
Provide a short and direct response. 14.4. What is the difference between the Value added (% of GDP) of Sub-Saharan Africa (developing only) in 2013 and the Value added (% of GDP) of Qatar in 2014?
Provide a succinct answer. 14.6. What is the difference between the Value added (% of GDP) of Bulgaria in 2013 and the Value added (% of GDP) of Luxembourg in 2014?
Ensure brevity in your answer.  5.04. What is the difference between the Value added (% of GDP) in Bulgaria in 2013 and the Value added (% of GDP) in Qatar in 2014?
Your response must be concise. 5.24. What is the difference between the Value added (% of GDP) of Luxembourg in 2013 and the Value added (% of GDP) of Qatar in 2014?
Offer a terse response. 0.19. What is the average Value added (% of GDP) in Sub-Saharan Africa (developing only) per year?
Offer a very short reply. 15.87. What is the average Value added (% of GDP) of Bulgaria per year?
Ensure brevity in your answer.  5.43. What is the average Value added (% of GDP) of Luxembourg per year?
Ensure brevity in your answer.  0.33. What is the average Value added (% of GDP) in Qatar per year?
Offer a terse response. 0.11. In the year 2007, what is the difference between the Value added (% of GDP) of Sub-Saharan Africa (developing only) and Value added (% of GDP) of Bulgaria?
Keep it short and to the point. 11.33. In the year 2007, what is the difference between the Value added (% of GDP) of Sub-Saharan Africa (developing only) and Value added (% of GDP) of Luxembourg?
Ensure brevity in your answer.  16.3. In the year 2007, what is the difference between the Value added (% of GDP) in Sub-Saharan Africa (developing only) and Value added (% of GDP) in Qatar?
Give a very brief answer. 16.65. In the year 2007, what is the difference between the Value added (% of GDP) of Bulgaria and Value added (% of GDP) of Luxembourg?
Your answer should be compact. 4.97. In the year 2007, what is the difference between the Value added (% of GDP) of Bulgaria and Value added (% of GDP) of Qatar?
Give a very brief answer. 5.32. In the year 2007, what is the difference between the Value added (% of GDP) of Luxembourg and Value added (% of GDP) of Qatar?
Provide a short and direct response. 0.35. In the year 2008, what is the difference between the Value added (% of GDP) of Sub-Saharan Africa (developing only) and Value added (% of GDP) of Bulgaria?
Keep it short and to the point. 10.24. In the year 2008, what is the difference between the Value added (% of GDP) of Sub-Saharan Africa (developing only) and Value added (% of GDP) of Luxembourg?
Your answer should be compact. 16.84. In the year 2008, what is the difference between the Value added (% of GDP) in Sub-Saharan Africa (developing only) and Value added (% of GDP) in Qatar?
Give a very brief answer. 17.07. In the year 2008, what is the difference between the Value added (% of GDP) of Bulgaria and Value added (% of GDP) of Luxembourg?
Ensure brevity in your answer.  6.6. In the year 2008, what is the difference between the Value added (% of GDP) of Bulgaria and Value added (% of GDP) of Qatar?
Provide a succinct answer. 6.83. In the year 2008, what is the difference between the Value added (% of GDP) in Luxembourg and Value added (% of GDP) in Qatar?
Provide a succinct answer. 0.23. In the year 2009, what is the difference between the Value added (% of GDP) of Sub-Saharan Africa (developing only) and Value added (% of GDP) of Bulgaria?
Your answer should be very brief. 12.98. In the year 2009, what is the difference between the Value added (% of GDP) in Sub-Saharan Africa (developing only) and Value added (% of GDP) in Luxembourg?
Keep it short and to the point. 17.59. In the year 2009, what is the difference between the Value added (% of GDP) of Sub-Saharan Africa (developing only) and Value added (% of GDP) of Qatar?
Give a very brief answer. 17.75. In the year 2009, what is the difference between the Value added (% of GDP) of Bulgaria and Value added (% of GDP) of Luxembourg?
Offer a terse response. 4.61. In the year 2009, what is the difference between the Value added (% of GDP) of Bulgaria and Value added (% of GDP) of Qatar?
Ensure brevity in your answer.  4.77. In the year 2009, what is the difference between the Value added (% of GDP) in Luxembourg and Value added (% of GDP) in Qatar?
Offer a terse response. 0.16. In the year 2010, what is the difference between the Value added (% of GDP) in Sub-Saharan Africa (developing only) and Value added (% of GDP) in Bulgaria?
Your response must be concise. 10.56. In the year 2010, what is the difference between the Value added (% of GDP) in Sub-Saharan Africa (developing only) and Value added (% of GDP) in Luxembourg?
Your answer should be very brief. 15.23. In the year 2010, what is the difference between the Value added (% of GDP) in Sub-Saharan Africa (developing only) and Value added (% of GDP) in Qatar?
Your response must be concise. 15.39. In the year 2010, what is the difference between the Value added (% of GDP) of Bulgaria and Value added (% of GDP) of Luxembourg?
Make the answer very short. 4.67. In the year 2010, what is the difference between the Value added (% of GDP) in Bulgaria and Value added (% of GDP) in Qatar?
Provide a short and direct response. 4.83. In the year 2010, what is the difference between the Value added (% of GDP) in Luxembourg and Value added (% of GDP) in Qatar?
Give a very brief answer. 0.16. In the year 2011, what is the difference between the Value added (% of GDP) of Sub-Saharan Africa (developing only) and Value added (% of GDP) of Bulgaria?
Offer a very short reply. 9.8. In the year 2011, what is the difference between the Value added (% of GDP) in Sub-Saharan Africa (developing only) and Value added (% of GDP) in Luxembourg?
Provide a succinct answer. 14.82. In the year 2011, what is the difference between the Value added (% of GDP) in Sub-Saharan Africa (developing only) and Value added (% of GDP) in Qatar?
Keep it short and to the point. 15.01. In the year 2011, what is the difference between the Value added (% of GDP) in Bulgaria and Value added (% of GDP) in Luxembourg?
Offer a terse response. 5.02. In the year 2011, what is the difference between the Value added (% of GDP) of Bulgaria and Value added (% of GDP) of Qatar?
Ensure brevity in your answer.  5.2. In the year 2011, what is the difference between the Value added (% of GDP) in Luxembourg and Value added (% of GDP) in Qatar?
Ensure brevity in your answer.  0.19. In the year 2012, what is the difference between the Value added (% of GDP) in Sub-Saharan Africa (developing only) and Value added (% of GDP) in Bulgaria?
Offer a very short reply. 9.87. In the year 2012, what is the difference between the Value added (% of GDP) in Sub-Saharan Africa (developing only) and Value added (% of GDP) in Luxembourg?
Offer a very short reply. 14.78. In the year 2012, what is the difference between the Value added (% of GDP) in Sub-Saharan Africa (developing only) and Value added (% of GDP) in Qatar?
Ensure brevity in your answer.  15.09. In the year 2012, what is the difference between the Value added (% of GDP) of Bulgaria and Value added (% of GDP) of Luxembourg?
Keep it short and to the point. 4.91. In the year 2012, what is the difference between the Value added (% of GDP) in Bulgaria and Value added (% of GDP) in Qatar?
Your answer should be very brief. 5.22. In the year 2012, what is the difference between the Value added (% of GDP) of Luxembourg and Value added (% of GDP) of Qatar?
Your answer should be compact. 0.31. In the year 2013, what is the difference between the Value added (% of GDP) of Sub-Saharan Africa (developing only) and Value added (% of GDP) of Bulgaria?
Your answer should be very brief. 9.36. In the year 2013, what is the difference between the Value added (% of GDP) in Sub-Saharan Africa (developing only) and Value added (% of GDP) in Luxembourg?
Provide a short and direct response. 14.4. In the year 2013, what is the difference between the Value added (% of GDP) of Sub-Saharan Africa (developing only) and Value added (% of GDP) of Qatar?
Your answer should be very brief. 14.6. In the year 2013, what is the difference between the Value added (% of GDP) in Bulgaria and Value added (% of GDP) in Luxembourg?
Your answer should be very brief. 5.05. In the year 2013, what is the difference between the Value added (% of GDP) of Bulgaria and Value added (% of GDP) of Qatar?
Your response must be concise. 5.25. In the year 2013, what is the difference between the Value added (% of GDP) of Luxembourg and Value added (% of GDP) of Qatar?
Your answer should be very brief. 0.2. In the year 2014, what is the difference between the Value added (% of GDP) in Sub-Saharan Africa (developing only) and Value added (% of GDP) in Bulgaria?
Offer a terse response. 9.4. In the year 2014, what is the difference between the Value added (% of GDP) in Sub-Saharan Africa (developing only) and Value added (% of GDP) in Luxembourg?
Offer a very short reply. 14.36. In the year 2014, what is the difference between the Value added (% of GDP) of Sub-Saharan Africa (developing only) and Value added (% of GDP) of Qatar?
Make the answer very short. 14.56. In the year 2014, what is the difference between the Value added (% of GDP) of Bulgaria and Value added (% of GDP) of Luxembourg?
Your answer should be very brief. 4.97. In the year 2014, what is the difference between the Value added (% of GDP) of Bulgaria and Value added (% of GDP) of Qatar?
Keep it short and to the point. 5.17. In the year 2014, what is the difference between the Value added (% of GDP) of Luxembourg and Value added (% of GDP) of Qatar?
Your answer should be very brief. 0.2. What is the ratio of the Value added (% of GDP) of Sub-Saharan Africa (developing only) in 2007 to that in 2008?
Ensure brevity in your answer.  0.97. What is the ratio of the Value added (% of GDP) in Bulgaria in 2007 to that in 2008?
Offer a terse response. 0.78. What is the ratio of the Value added (% of GDP) of Luxembourg in 2007 to that in 2008?
Your answer should be compact. 1.31. What is the ratio of the Value added (% of GDP) in Qatar in 2007 to that in 2008?
Ensure brevity in your answer.  0.88. What is the ratio of the Value added (% of GDP) of Sub-Saharan Africa (developing only) in 2007 to that in 2009?
Ensure brevity in your answer.  0.94. What is the ratio of the Value added (% of GDP) of Bulgaria in 2007 to that in 2009?
Provide a succinct answer. 1.11. What is the ratio of the Value added (% of GDP) in Luxembourg in 2007 to that in 2009?
Provide a succinct answer. 1.62. What is the ratio of the Value added (% of GDP) in Qatar in 2007 to that in 2009?
Offer a terse response. 0.89. What is the ratio of the Value added (% of GDP) in Sub-Saharan Africa (developing only) in 2007 to that in 2010?
Give a very brief answer. 1.08. What is the ratio of the Value added (% of GDP) of Bulgaria in 2007 to that in 2010?
Provide a succinct answer. 1.1. What is the ratio of the Value added (% of GDP) of Luxembourg in 2007 to that in 2010?
Your answer should be compact. 1.65. What is the ratio of the Value added (% of GDP) in Qatar in 2007 to that in 2010?
Provide a short and direct response. 0.93. What is the ratio of the Value added (% of GDP) in Sub-Saharan Africa (developing only) in 2007 to that in 2011?
Give a very brief answer. 1.11. What is the ratio of the Value added (% of GDP) in Bulgaria in 2007 to that in 2011?
Your response must be concise. 1.02. What is the ratio of the Value added (% of GDP) in Luxembourg in 2007 to that in 2011?
Your answer should be very brief. 1.63. What is the ratio of the Value added (% of GDP) in Qatar in 2007 to that in 2011?
Keep it short and to the point. 1.15. What is the ratio of the Value added (% of GDP) of Sub-Saharan Africa (developing only) in 2007 to that in 2012?
Provide a short and direct response. 1.1. What is the ratio of the Value added (% of GDP) of Bulgaria in 2007 to that in 2012?
Make the answer very short. 1.02. What is the ratio of the Value added (% of GDP) in Luxembourg in 2007 to that in 2012?
Your answer should be compact. 1.14. What is the ratio of the Value added (% of GDP) in Qatar in 2007 to that in 2012?
Your answer should be very brief. 1.19. What is the ratio of the Value added (% of GDP) of Sub-Saharan Africa (developing only) in 2007 to that in 2013?
Make the answer very short. 1.14. What is the ratio of the Value added (% of GDP) in Bulgaria in 2007 to that in 2013?
Offer a terse response. 1.02. What is the ratio of the Value added (% of GDP) of Luxembourg in 2007 to that in 2013?
Make the answer very short. 1.57. What is the ratio of the Value added (% of GDP) of Qatar in 2007 to that in 2013?
Give a very brief answer. 1.16. What is the ratio of the Value added (% of GDP) of Sub-Saharan Africa (developing only) in 2007 to that in 2014?
Provide a succinct answer. 1.14. What is the ratio of the Value added (% of GDP) of Bulgaria in 2007 to that in 2014?
Provide a short and direct response. 1.03. What is the ratio of the Value added (% of GDP) of Luxembourg in 2007 to that in 2014?
Provide a short and direct response. 1.55. What is the ratio of the Value added (% of GDP) of Qatar in 2007 to that in 2014?
Your response must be concise. 1.1. What is the ratio of the Value added (% of GDP) in Sub-Saharan Africa (developing only) in 2008 to that in 2009?
Offer a terse response. 0.96. What is the ratio of the Value added (% of GDP) of Bulgaria in 2008 to that in 2009?
Offer a terse response. 1.42. What is the ratio of the Value added (% of GDP) of Luxembourg in 2008 to that in 2009?
Provide a succinct answer. 1.23. What is the ratio of the Value added (% of GDP) in Qatar in 2008 to that in 2009?
Make the answer very short. 1.01. What is the ratio of the Value added (% of GDP) in Sub-Saharan Africa (developing only) in 2008 to that in 2010?
Make the answer very short. 1.11. What is the ratio of the Value added (% of GDP) of Bulgaria in 2008 to that in 2010?
Give a very brief answer. 1.41. What is the ratio of the Value added (% of GDP) of Luxembourg in 2008 to that in 2010?
Your response must be concise. 1.25. What is the ratio of the Value added (% of GDP) of Qatar in 2008 to that in 2010?
Your answer should be very brief. 1.06. What is the ratio of the Value added (% of GDP) in Sub-Saharan Africa (developing only) in 2008 to that in 2011?
Make the answer very short. 1.14. What is the ratio of the Value added (% of GDP) of Bulgaria in 2008 to that in 2011?
Keep it short and to the point. 1.31. What is the ratio of the Value added (% of GDP) of Luxembourg in 2008 to that in 2011?
Keep it short and to the point. 1.24. What is the ratio of the Value added (% of GDP) in Qatar in 2008 to that in 2011?
Provide a succinct answer. 1.31. What is the ratio of the Value added (% of GDP) of Sub-Saharan Africa (developing only) in 2008 to that in 2012?
Ensure brevity in your answer.  1.13. What is the ratio of the Value added (% of GDP) of Bulgaria in 2008 to that in 2012?
Provide a short and direct response. 1.31. What is the ratio of the Value added (% of GDP) of Luxembourg in 2008 to that in 2012?
Ensure brevity in your answer.  0.87. What is the ratio of the Value added (% of GDP) in Qatar in 2008 to that in 2012?
Your response must be concise. 1.35. What is the ratio of the Value added (% of GDP) in Sub-Saharan Africa (developing only) in 2008 to that in 2013?
Your answer should be compact. 1.17. What is the ratio of the Value added (% of GDP) in Bulgaria in 2008 to that in 2013?
Your response must be concise. 1.3. What is the ratio of the Value added (% of GDP) of Luxembourg in 2008 to that in 2013?
Your answer should be very brief. 1.2. What is the ratio of the Value added (% of GDP) of Qatar in 2008 to that in 2013?
Ensure brevity in your answer.  1.32. What is the ratio of the Value added (% of GDP) in Sub-Saharan Africa (developing only) in 2008 to that in 2014?
Your answer should be compact. 1.17. What is the ratio of the Value added (% of GDP) of Bulgaria in 2008 to that in 2014?
Provide a short and direct response. 1.32. What is the ratio of the Value added (% of GDP) of Luxembourg in 2008 to that in 2014?
Your response must be concise. 1.18. What is the ratio of the Value added (% of GDP) in Qatar in 2008 to that in 2014?
Your answer should be compact. 1.25. What is the ratio of the Value added (% of GDP) in Sub-Saharan Africa (developing only) in 2009 to that in 2010?
Your answer should be compact. 1.15. What is the ratio of the Value added (% of GDP) of Bulgaria in 2009 to that in 2010?
Offer a terse response. 0.99. What is the ratio of the Value added (% of GDP) of Luxembourg in 2009 to that in 2010?
Provide a short and direct response. 1.02. What is the ratio of the Value added (% of GDP) of Qatar in 2009 to that in 2010?
Provide a succinct answer. 1.05. What is the ratio of the Value added (% of GDP) of Sub-Saharan Africa (developing only) in 2009 to that in 2011?
Keep it short and to the point. 1.18. What is the ratio of the Value added (% of GDP) in Bulgaria in 2009 to that in 2011?
Give a very brief answer. 0.92. What is the ratio of the Value added (% of GDP) of Luxembourg in 2009 to that in 2011?
Provide a succinct answer. 1.01. What is the ratio of the Value added (% of GDP) in Qatar in 2009 to that in 2011?
Ensure brevity in your answer.  1.29. What is the ratio of the Value added (% of GDP) in Sub-Saharan Africa (developing only) in 2009 to that in 2012?
Your answer should be compact. 1.18. What is the ratio of the Value added (% of GDP) of Bulgaria in 2009 to that in 2012?
Your response must be concise. 0.92. What is the ratio of the Value added (% of GDP) of Luxembourg in 2009 to that in 2012?
Your answer should be compact. 0.71. What is the ratio of the Value added (% of GDP) of Qatar in 2009 to that in 2012?
Provide a short and direct response. 1.33. What is the ratio of the Value added (% of GDP) in Sub-Saharan Africa (developing only) in 2009 to that in 2013?
Provide a short and direct response. 1.22. What is the ratio of the Value added (% of GDP) in Bulgaria in 2009 to that in 2013?
Your response must be concise. 0.92. What is the ratio of the Value added (% of GDP) in Luxembourg in 2009 to that in 2013?
Give a very brief answer. 0.97. What is the ratio of the Value added (% of GDP) of Qatar in 2009 to that in 2013?
Your answer should be very brief. 1.3. What is the ratio of the Value added (% of GDP) in Sub-Saharan Africa (developing only) in 2009 to that in 2014?
Your answer should be compact. 1.22. What is the ratio of the Value added (% of GDP) in Bulgaria in 2009 to that in 2014?
Your response must be concise. 0.93. What is the ratio of the Value added (% of GDP) in Luxembourg in 2009 to that in 2014?
Your response must be concise. 0.96. What is the ratio of the Value added (% of GDP) in Qatar in 2009 to that in 2014?
Provide a short and direct response. 1.24. What is the ratio of the Value added (% of GDP) of Sub-Saharan Africa (developing only) in 2010 to that in 2011?
Your response must be concise. 1.03. What is the ratio of the Value added (% of GDP) in Bulgaria in 2010 to that in 2011?
Offer a terse response. 0.93. What is the ratio of the Value added (% of GDP) of Luxembourg in 2010 to that in 2011?
Offer a very short reply. 0.99. What is the ratio of the Value added (% of GDP) in Qatar in 2010 to that in 2011?
Your answer should be compact. 1.24. What is the ratio of the Value added (% of GDP) of Sub-Saharan Africa (developing only) in 2010 to that in 2012?
Your answer should be compact. 1.02. What is the ratio of the Value added (% of GDP) of Bulgaria in 2010 to that in 2012?
Provide a succinct answer. 0.93. What is the ratio of the Value added (% of GDP) of Luxembourg in 2010 to that in 2012?
Provide a succinct answer. 0.69. What is the ratio of the Value added (% of GDP) of Qatar in 2010 to that in 2012?
Your answer should be compact. 1.27. What is the ratio of the Value added (% of GDP) of Sub-Saharan Africa (developing only) in 2010 to that in 2013?
Offer a very short reply. 1.06. What is the ratio of the Value added (% of GDP) of Bulgaria in 2010 to that in 2013?
Offer a very short reply. 0.93. What is the ratio of the Value added (% of GDP) of Luxembourg in 2010 to that in 2013?
Make the answer very short. 0.95. What is the ratio of the Value added (% of GDP) of Qatar in 2010 to that in 2013?
Your answer should be very brief. 1.25. What is the ratio of the Value added (% of GDP) of Sub-Saharan Africa (developing only) in 2010 to that in 2014?
Your answer should be compact. 1.06. What is the ratio of the Value added (% of GDP) of Bulgaria in 2010 to that in 2014?
Your answer should be very brief. 0.94. What is the ratio of the Value added (% of GDP) in Luxembourg in 2010 to that in 2014?
Ensure brevity in your answer.  0.94. What is the ratio of the Value added (% of GDP) in Qatar in 2010 to that in 2014?
Your response must be concise. 1.18. What is the ratio of the Value added (% of GDP) in Sub-Saharan Africa (developing only) in 2011 to that in 2012?
Provide a short and direct response. 0.99. What is the ratio of the Value added (% of GDP) in Bulgaria in 2011 to that in 2012?
Your answer should be compact. 1. What is the ratio of the Value added (% of GDP) in Luxembourg in 2011 to that in 2012?
Provide a short and direct response. 0.7. What is the ratio of the Value added (% of GDP) in Qatar in 2011 to that in 2012?
Your answer should be compact. 1.03. What is the ratio of the Value added (% of GDP) in Sub-Saharan Africa (developing only) in 2011 to that in 2013?
Offer a very short reply. 1.03. What is the ratio of the Value added (% of GDP) of Luxembourg in 2011 to that in 2013?
Provide a succinct answer. 0.96. What is the ratio of the Value added (% of GDP) of Qatar in 2011 to that in 2013?
Give a very brief answer. 1.01. What is the ratio of the Value added (% of GDP) in Sub-Saharan Africa (developing only) in 2011 to that in 2014?
Offer a terse response. 1.03. What is the ratio of the Value added (% of GDP) of Luxembourg in 2011 to that in 2014?
Your answer should be compact. 0.95. What is the ratio of the Value added (% of GDP) in Qatar in 2011 to that in 2014?
Give a very brief answer. 0.96. What is the ratio of the Value added (% of GDP) in Sub-Saharan Africa (developing only) in 2012 to that in 2013?
Your answer should be compact. 1.03. What is the ratio of the Value added (% of GDP) in Bulgaria in 2012 to that in 2013?
Your answer should be compact. 1. What is the ratio of the Value added (% of GDP) in Luxembourg in 2012 to that in 2013?
Keep it short and to the point. 1.38. What is the ratio of the Value added (% of GDP) of Qatar in 2012 to that in 2013?
Ensure brevity in your answer.  0.98. What is the ratio of the Value added (% of GDP) in Sub-Saharan Africa (developing only) in 2012 to that in 2014?
Offer a terse response. 1.04. What is the ratio of the Value added (% of GDP) of Bulgaria in 2012 to that in 2014?
Offer a terse response. 1.01. What is the ratio of the Value added (% of GDP) in Luxembourg in 2012 to that in 2014?
Keep it short and to the point. 1.35. What is the ratio of the Value added (% of GDP) of Qatar in 2012 to that in 2014?
Ensure brevity in your answer.  0.93. What is the ratio of the Value added (% of GDP) in Sub-Saharan Africa (developing only) in 2013 to that in 2014?
Provide a short and direct response. 1. What is the ratio of the Value added (% of GDP) in Bulgaria in 2013 to that in 2014?
Your answer should be very brief. 1.01. What is the ratio of the Value added (% of GDP) of Luxembourg in 2013 to that in 2014?
Ensure brevity in your answer.  0.99. What is the ratio of the Value added (% of GDP) in Qatar in 2013 to that in 2014?
Provide a succinct answer. 0.95. What is the difference between the highest and the second highest Value added (% of GDP) in Sub-Saharan Africa (developing only)?
Provide a short and direct response. 0.68. What is the difference between the highest and the second highest Value added (% of GDP) in Bulgaria?
Make the answer very short. 1.52. What is the difference between the highest and the second highest Value added (% of GDP) in Luxembourg?
Make the answer very short. 0.06. What is the difference between the highest and the second highest Value added (% of GDP) of Qatar?
Make the answer very short. 0. What is the difference between the highest and the lowest Value added (% of GDP) in Sub-Saharan Africa (developing only)?
Offer a very short reply. 3.21. What is the difference between the highest and the lowest Value added (% of GDP) of Bulgaria?
Your response must be concise. 2.06. What is the difference between the highest and the lowest Value added (% of GDP) of Luxembourg?
Offer a very short reply. 0.18. What is the difference between the highest and the lowest Value added (% of GDP) in Qatar?
Provide a short and direct response. 0.03. 